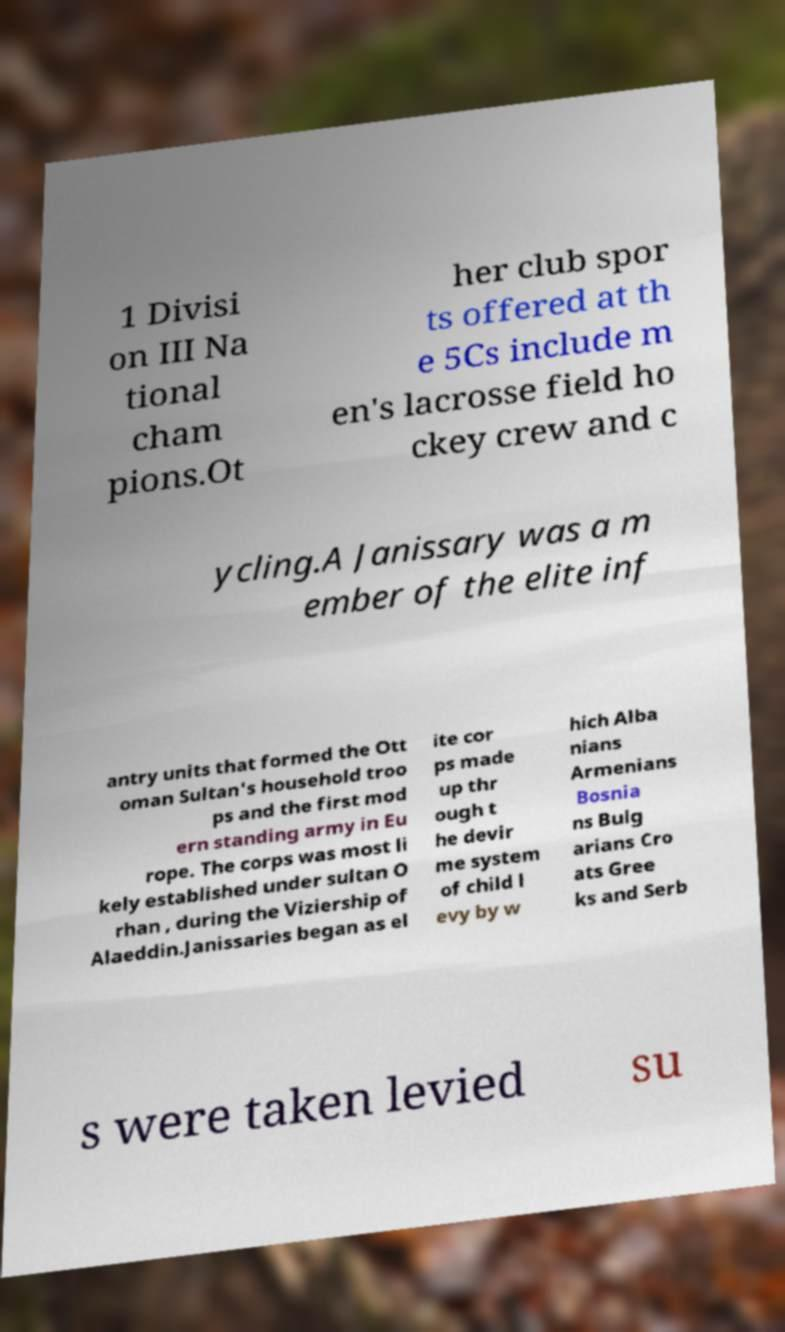Please read and relay the text visible in this image. What does it say? 1 Divisi on III Na tional cham pions.Ot her club spor ts offered at th e 5Cs include m en's lacrosse field ho ckey crew and c ycling.A Janissary was a m ember of the elite inf antry units that formed the Ott oman Sultan's household troo ps and the first mod ern standing army in Eu rope. The corps was most li kely established under sultan O rhan , during the Viziership of Alaeddin.Janissaries began as el ite cor ps made up thr ough t he devir me system of child l evy by w hich Alba nians Armenians Bosnia ns Bulg arians Cro ats Gree ks and Serb s were taken levied su 